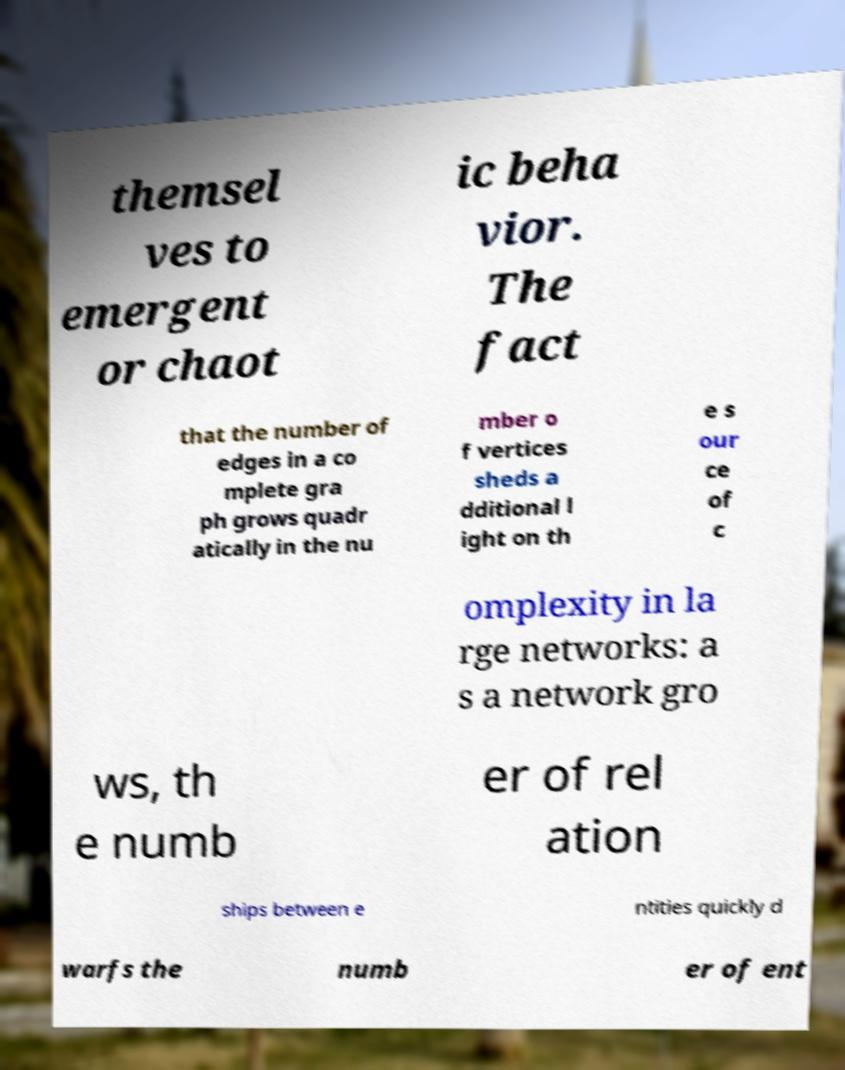Can you accurately transcribe the text from the provided image for me? themsel ves to emergent or chaot ic beha vior. The fact that the number of edges in a co mplete gra ph grows quadr atically in the nu mber o f vertices sheds a dditional l ight on th e s our ce of c omplexity in la rge networks: a s a network gro ws, th e numb er of rel ation ships between e ntities quickly d warfs the numb er of ent 